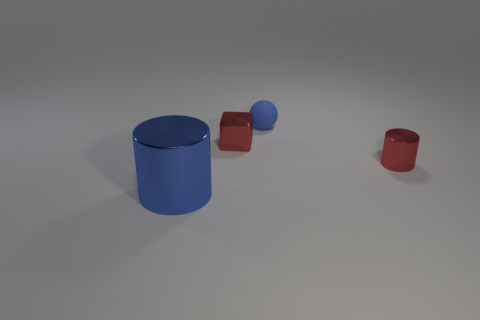Add 2 rubber balls. How many objects exist? 6 Subtract all blocks. How many objects are left? 3 Subtract 0 blue blocks. How many objects are left? 4 Subtract all rubber objects. Subtract all small blue things. How many objects are left? 2 Add 3 balls. How many balls are left? 4 Add 4 large red metal objects. How many large red metal objects exist? 4 